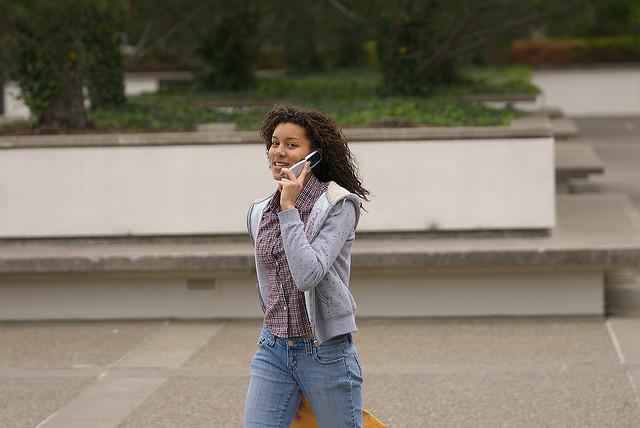What is the object the woman has next to her face?
Give a very brief answer. Cell phone. What is the mime doing?
Keep it brief. Talking on cell phone. What the woman doing?
Concise answer only. Talking on phone. What color is the girl's phone?
Keep it brief. Silver. Is the woman wearing a dress?
Be succinct. No. What color is the woman's jeans?
Give a very brief answer. Blue. 